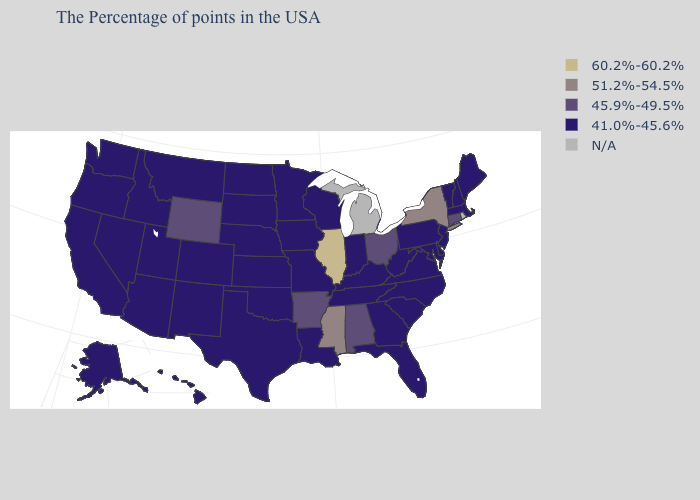Name the states that have a value in the range 60.2%-60.2%?
Give a very brief answer. Illinois. Does the first symbol in the legend represent the smallest category?
Be succinct. No. What is the value of Tennessee?
Answer briefly. 41.0%-45.6%. What is the value of Maine?
Short answer required. 41.0%-45.6%. Among the states that border New Jersey , which have the lowest value?
Keep it brief. Delaware, Pennsylvania. What is the value of Kansas?
Keep it brief. 41.0%-45.6%. Does Colorado have the lowest value in the West?
Quick response, please. Yes. What is the highest value in states that border Nebraska?
Short answer required. 45.9%-49.5%. What is the value of West Virginia?
Be succinct. 41.0%-45.6%. What is the value of Minnesota?
Concise answer only. 41.0%-45.6%. Which states hav the highest value in the South?
Be succinct. Mississippi. What is the value of West Virginia?
Short answer required. 41.0%-45.6%. Does Florida have the lowest value in the USA?
Short answer required. Yes. What is the value of Montana?
Answer briefly. 41.0%-45.6%. 